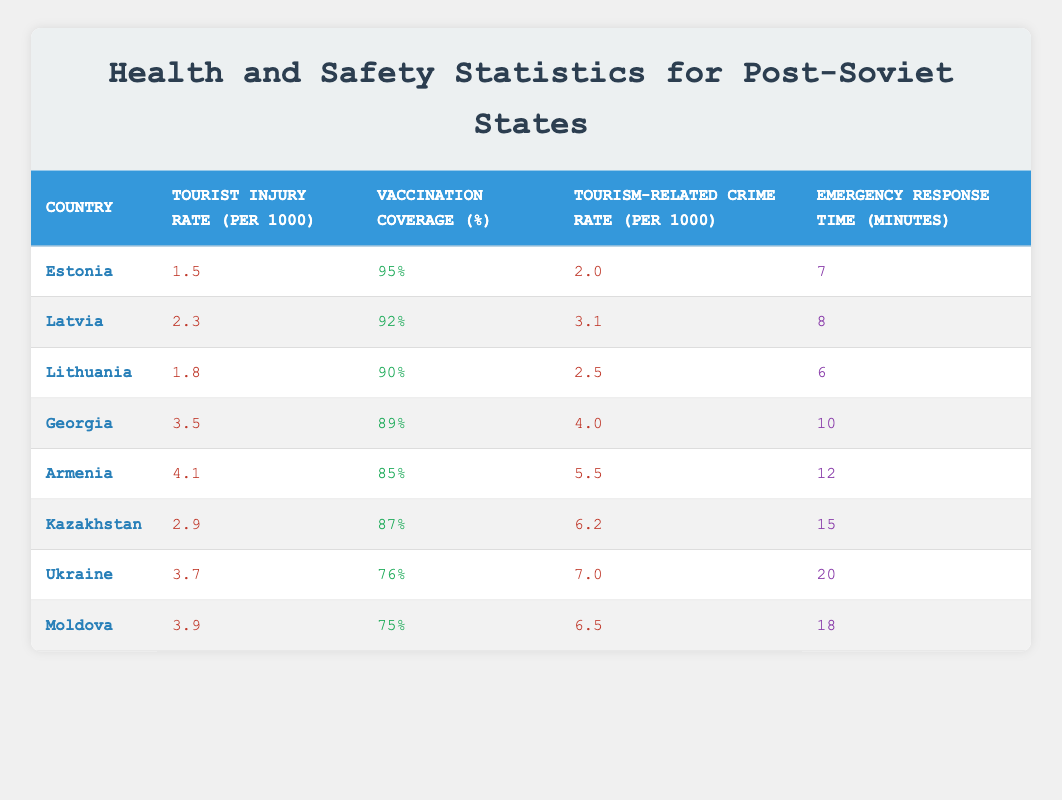What is the tourist injury rate in Estonia? The table lists Estonia's tourist injury rate under the "Tourist Injury Rate (per 1000)" column, which shows the value to be 1.5.
Answer: 1.5 Which country has the highest vaccination coverage percentage? Reviewing the "Vaccination Coverage (%)" column for each country, Estonia has the highest value at 95%.
Answer: 95% Is the emergency response time in Georgia less than 10 minutes? According to the "Emergency Response Time (minutes)" column, Georgia's response time is listed as 10 minutes, so it is not less than that.
Answer: No What is the average tourist injury rate for all the countries listed? The tourist injury rates for each country are: 1.5, 2.3, 1.8, 3.5, 4.1, 2.9, 3.7, 3.9. Adding them gives a total of 23.7 and dividing by 8 countries results in an average of 2.9625.
Answer: 2.96 Is the tourism-related crime rate in Latvia higher than that in Lithuania? In the "Tourism-Related Crime Rate (per 1000)" column, Latvia's rate is 3.1 while Lithuania's is 2.5. Since 3.1 is greater than 2.5, the statement is true.
Answer: Yes Which country has the longest emergency response time? Scanning through the "Emergency Response Time (minutes)" column, Ukraine has the longest response time listed at 20 minutes, compared to other countries.
Answer: 20 What is the difference in vaccination coverage percentage between Armenia and Kazakhstan? Armenia has a vaccination coverage of 85% and Kazakhstan has 87%. The difference is calculated as 87% - 85% = 2%.
Answer: 2% How many countries have a tourism-related crime rate greater than 5? By analyzing the "Tourism-Related Crime Rate (per 1000)" column, the countries with rates greater than 5 are Armenia (5.5), Kazakhstan (6.2), Ukraine (7.0), and Moldova (6.5), totaling four countries.
Answer: 4 What is the lowest tourist injury rate among the listed countries? Looking through the "Tourist Injury Rate (per 1000)", the lowest value is 1.5, which belongs to Estonia.
Answer: 1.5 